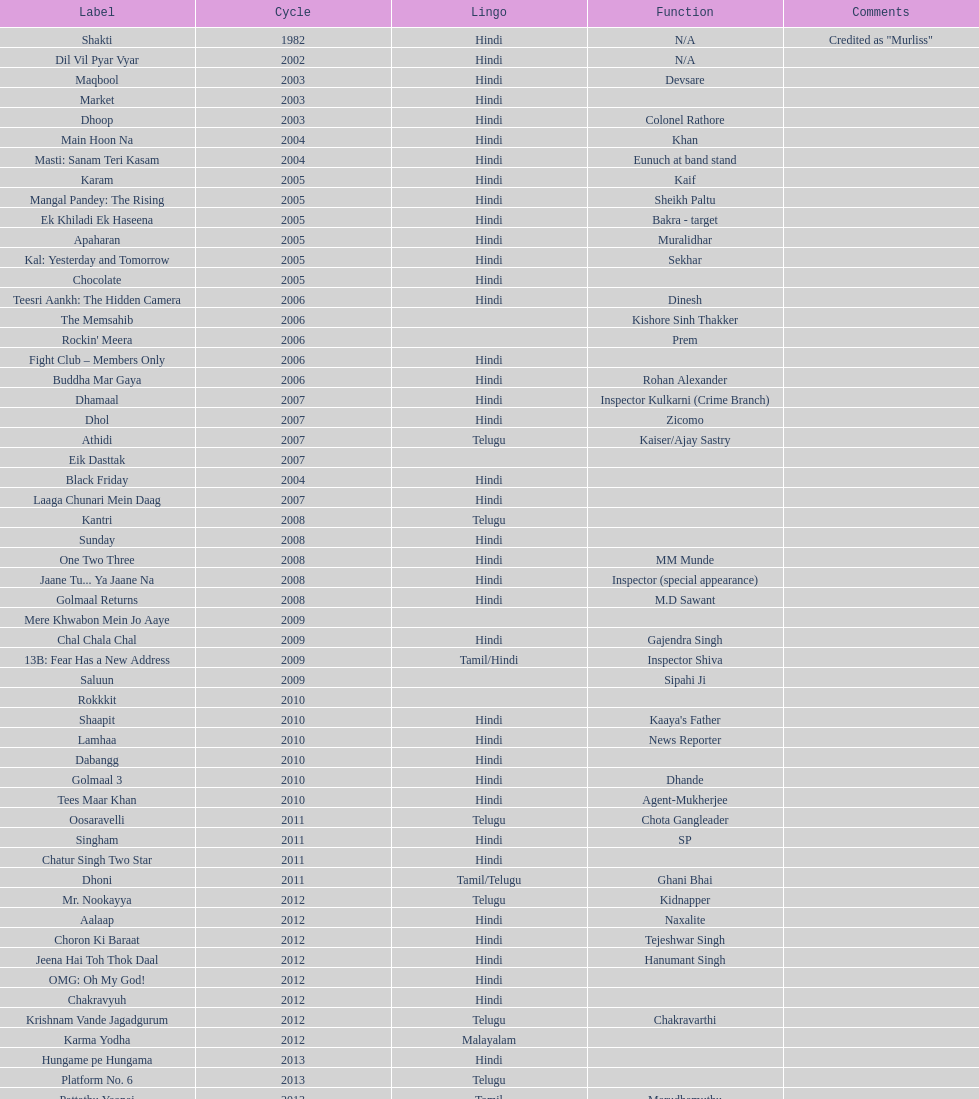What was the last malayalam film this actor starred in? Karma Yodha. 